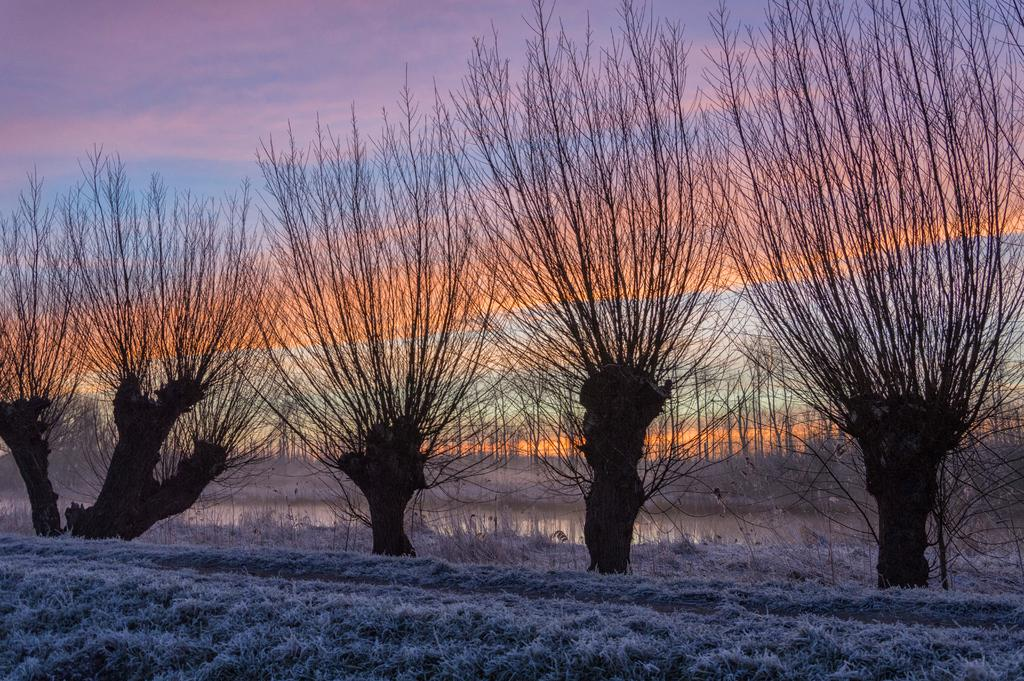What is the primary feature of the landscape in the image? There is grass covered with snow in the image. What can be seen in the background of the image? There are trees in the background of the image. What part of the natural environment is visible in the image? The sky is visible in the background of the image. Where can the pig be found in the image? There is no pig present in the image. What type of ticket is visible in the image? There is no ticket present in the image. What rail system is in use in the image? There is no rail system present in the image. 